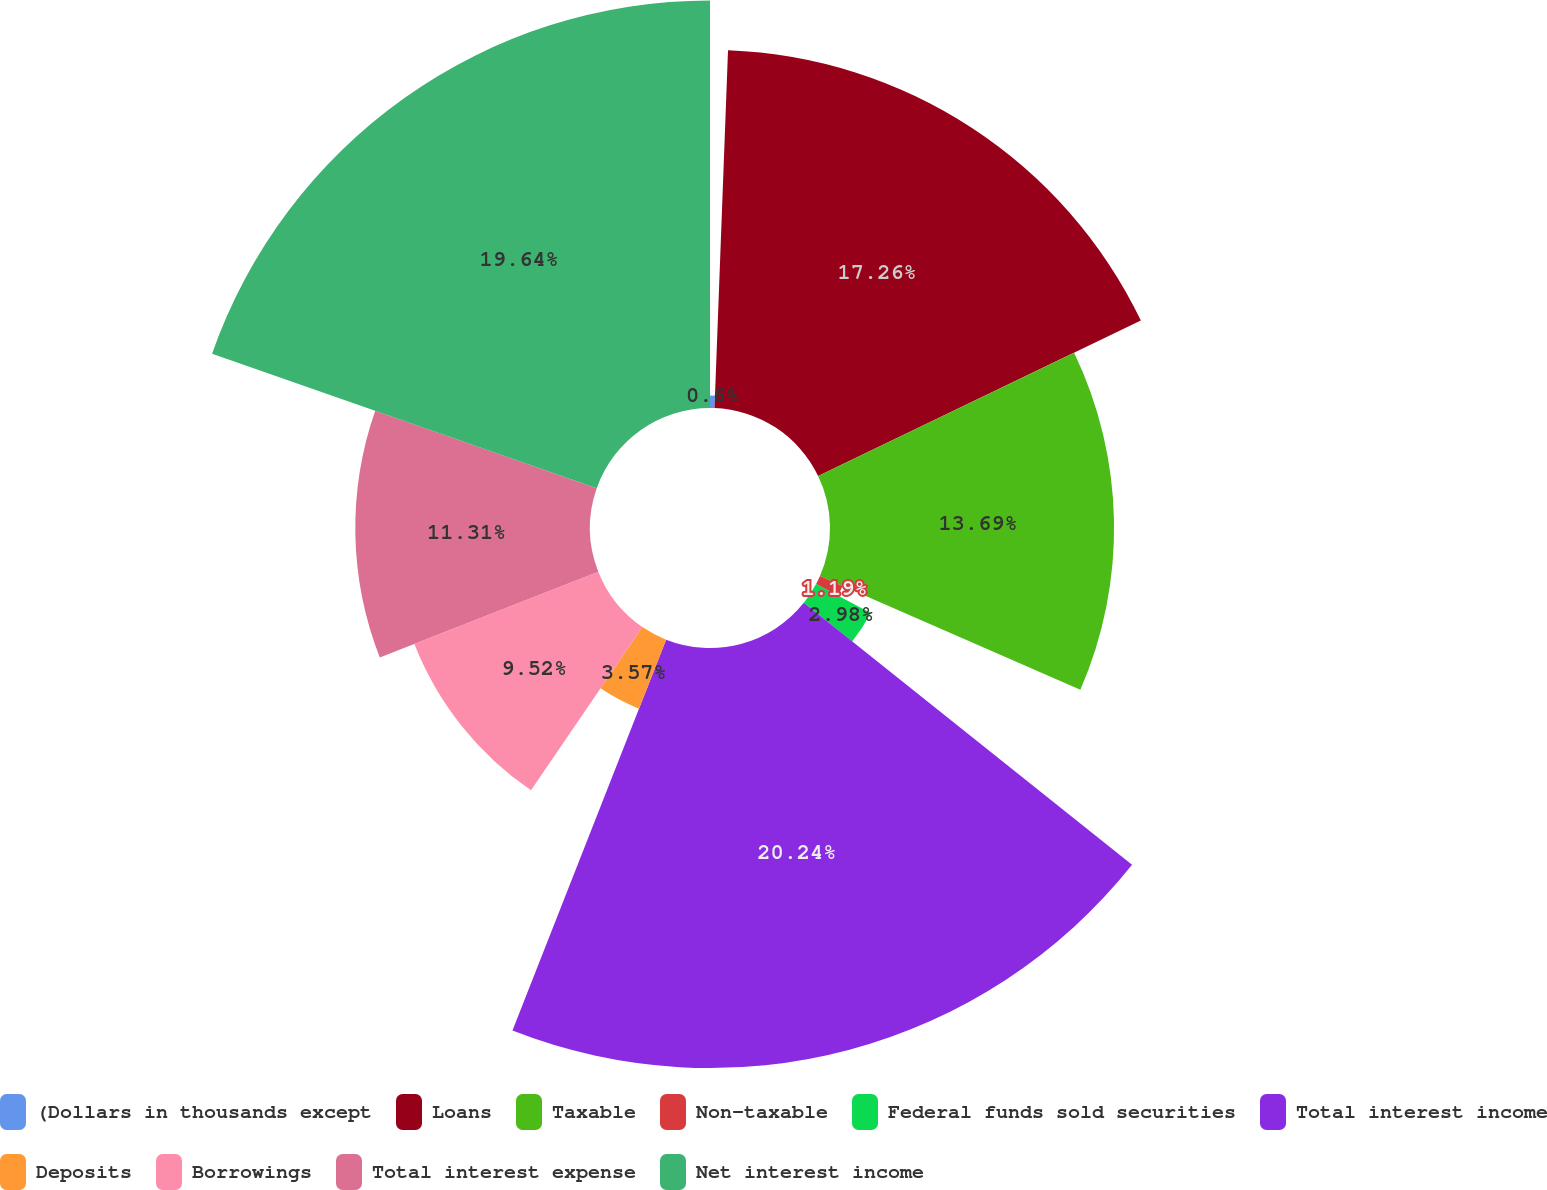Convert chart. <chart><loc_0><loc_0><loc_500><loc_500><pie_chart><fcel>(Dollars in thousands except<fcel>Loans<fcel>Taxable<fcel>Non-taxable<fcel>Federal funds sold securities<fcel>Total interest income<fcel>Deposits<fcel>Borrowings<fcel>Total interest expense<fcel>Net interest income<nl><fcel>0.6%<fcel>17.26%<fcel>13.69%<fcel>1.19%<fcel>2.98%<fcel>20.24%<fcel>3.57%<fcel>9.52%<fcel>11.31%<fcel>19.64%<nl></chart> 